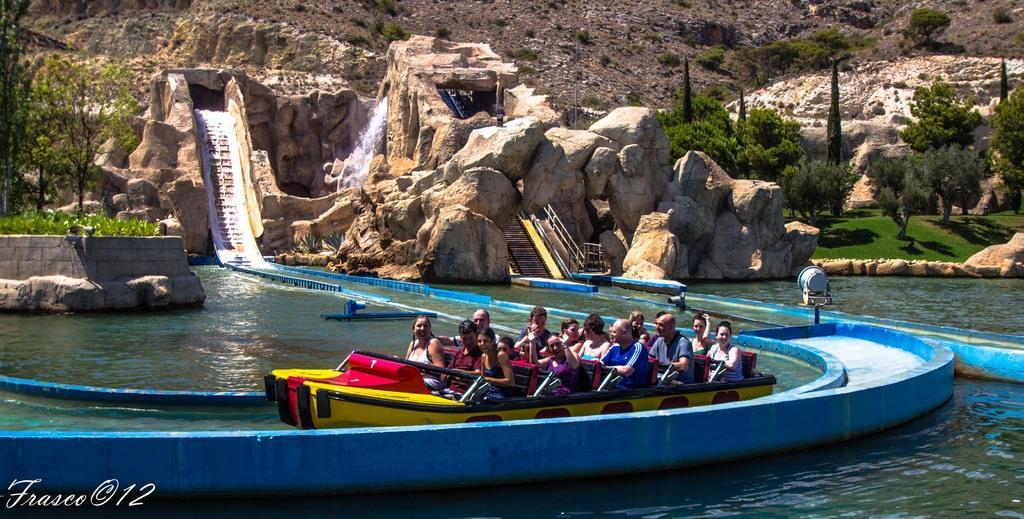Could you give a brief overview of what you see in this image? In this image there are a few people sitting on a water ride. Behind them there is a pool, water slides, metal rods, some objects, rocks and trees. At the bottom of the image there is some text. 